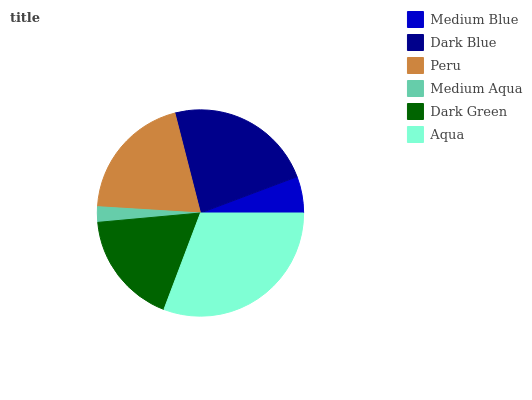Is Medium Aqua the minimum?
Answer yes or no. Yes. Is Aqua the maximum?
Answer yes or no. Yes. Is Dark Blue the minimum?
Answer yes or no. No. Is Dark Blue the maximum?
Answer yes or no. No. Is Dark Blue greater than Medium Blue?
Answer yes or no. Yes. Is Medium Blue less than Dark Blue?
Answer yes or no. Yes. Is Medium Blue greater than Dark Blue?
Answer yes or no. No. Is Dark Blue less than Medium Blue?
Answer yes or no. No. Is Peru the high median?
Answer yes or no. Yes. Is Dark Green the low median?
Answer yes or no. Yes. Is Dark Green the high median?
Answer yes or no. No. Is Dark Blue the low median?
Answer yes or no. No. 